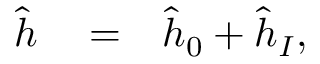<formula> <loc_0><loc_0><loc_500><loc_500>\begin{array} { r l r } { \hat { h } } & = } & { \hat { h } _ { 0 } + \hat { h } _ { I } , } \end{array}</formula> 